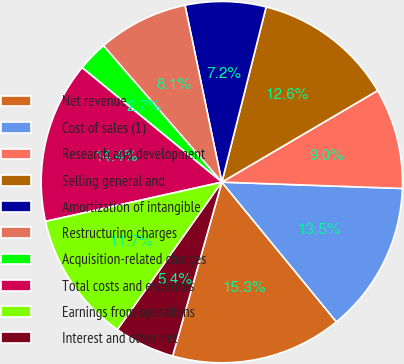<chart> <loc_0><loc_0><loc_500><loc_500><pie_chart><fcel>Net revenue<fcel>Cost of sales (1)<fcel>Research and development<fcel>Selling general and<fcel>Amortization of intangible<fcel>Restructuring charges<fcel>Acquisition-related charges<fcel>Total costs and expenses<fcel>Earnings from operations<fcel>Interest and other net<nl><fcel>15.32%<fcel>13.51%<fcel>9.01%<fcel>12.61%<fcel>7.21%<fcel>8.11%<fcel>2.7%<fcel>14.41%<fcel>11.71%<fcel>5.41%<nl></chart> 